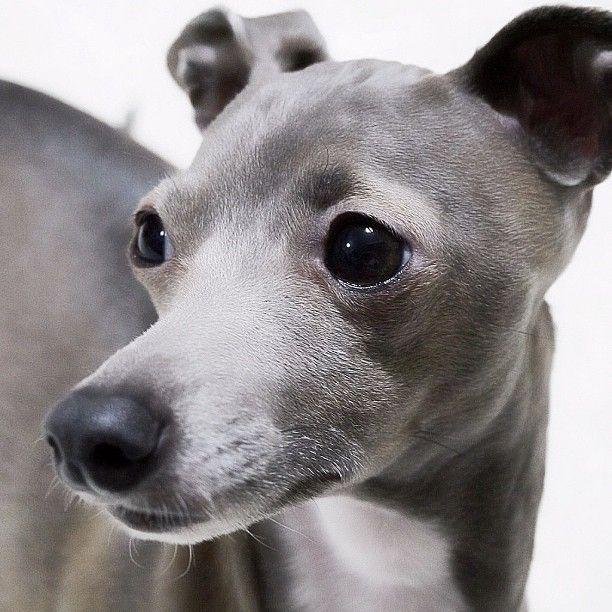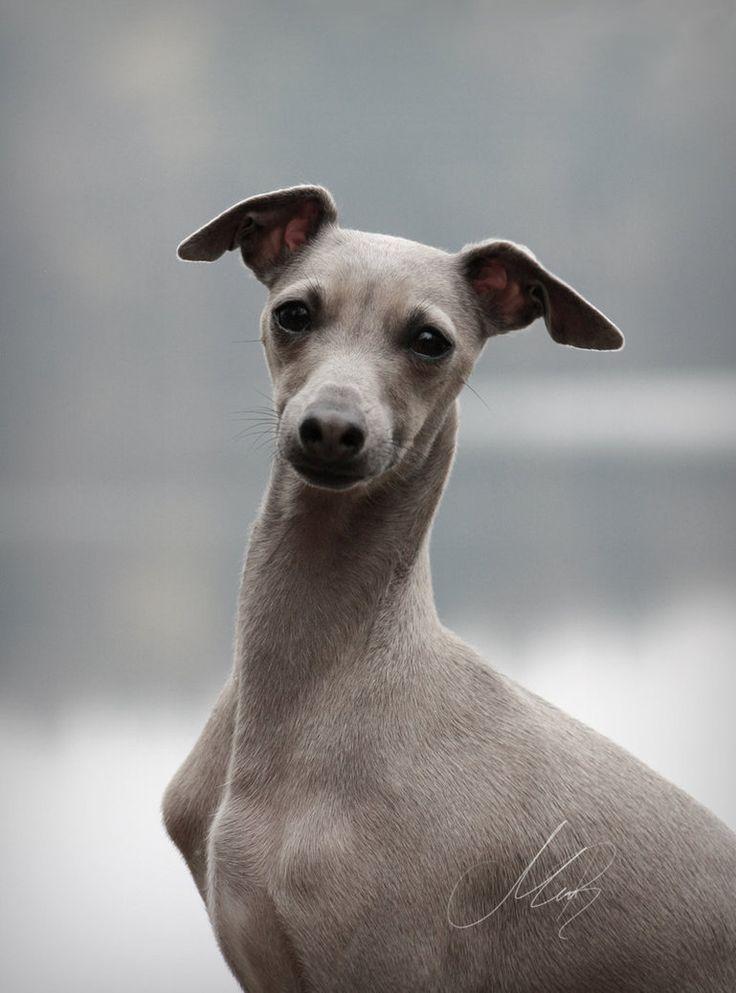The first image is the image on the left, the second image is the image on the right. For the images displayed, is the sentence "At least one dog is a solid color with no patches of white." factually correct? Answer yes or no. Yes. The first image is the image on the left, the second image is the image on the right. Given the left and right images, does the statement "The right image shows a gray-and-white dog that is craning its neck." hold true? Answer yes or no. No. 